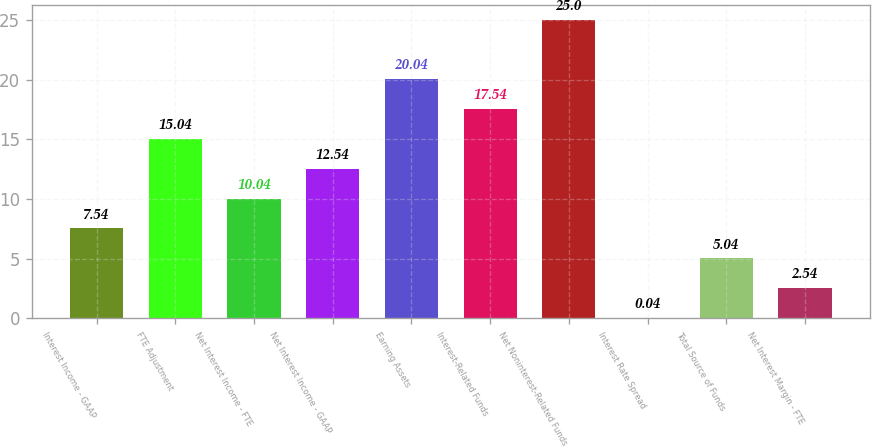<chart> <loc_0><loc_0><loc_500><loc_500><bar_chart><fcel>Interest Income - GAAP<fcel>FTE Adjustment<fcel>Net Interest Income - FTE<fcel>Net Interest Income - GAAP<fcel>Earning Assets<fcel>Interest-Related Funds<fcel>Net Noninterest-Related Funds<fcel>Interest Rate Spread<fcel>Total Source of Funds<fcel>Net Interest Margin - FTE<nl><fcel>7.54<fcel>15.04<fcel>10.04<fcel>12.54<fcel>20.04<fcel>17.54<fcel>25<fcel>0.04<fcel>5.04<fcel>2.54<nl></chart> 